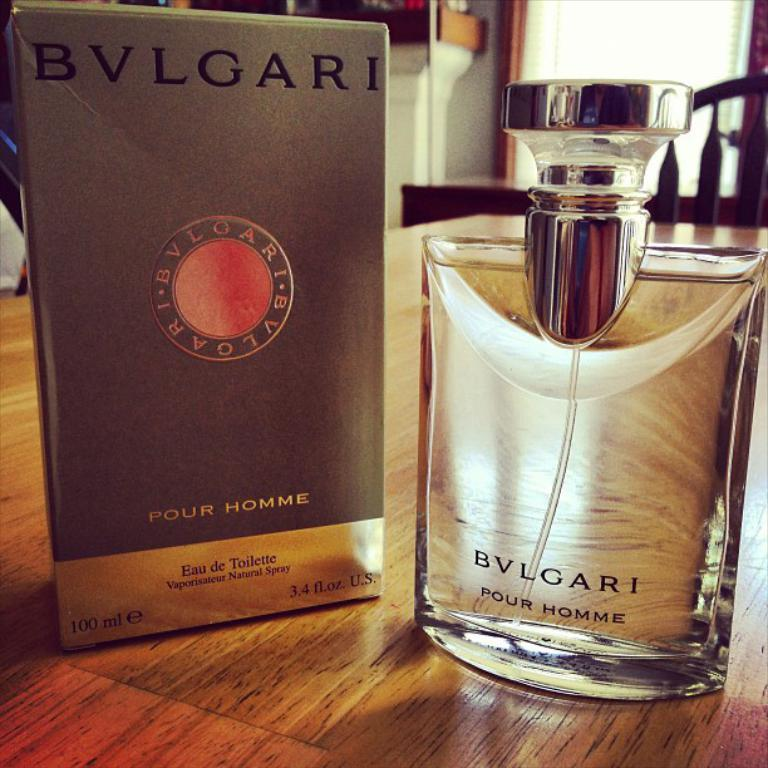<image>
Describe the image concisely. A bottle of Bvlgari perfume sits next to the box that it came in. 